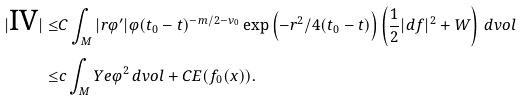<formula> <loc_0><loc_0><loc_500><loc_500>| \text {IV} | \leq & C \int _ { M } | r \varphi ^ { \prime } | \varphi ( t _ { 0 } - t ) ^ { - m / 2 - \nu _ { 0 } } \exp \left ( - r ^ { 2 } / 4 ( t _ { 0 } - t ) \right ) \left ( \frac { 1 } { 2 } | d f | ^ { 2 } + W \right ) \, d v o l \\ \leq & c \int _ { M } Y e \varphi ^ { 2 } \, d v o l + C E ( f _ { 0 } ( x ) ) .</formula> 